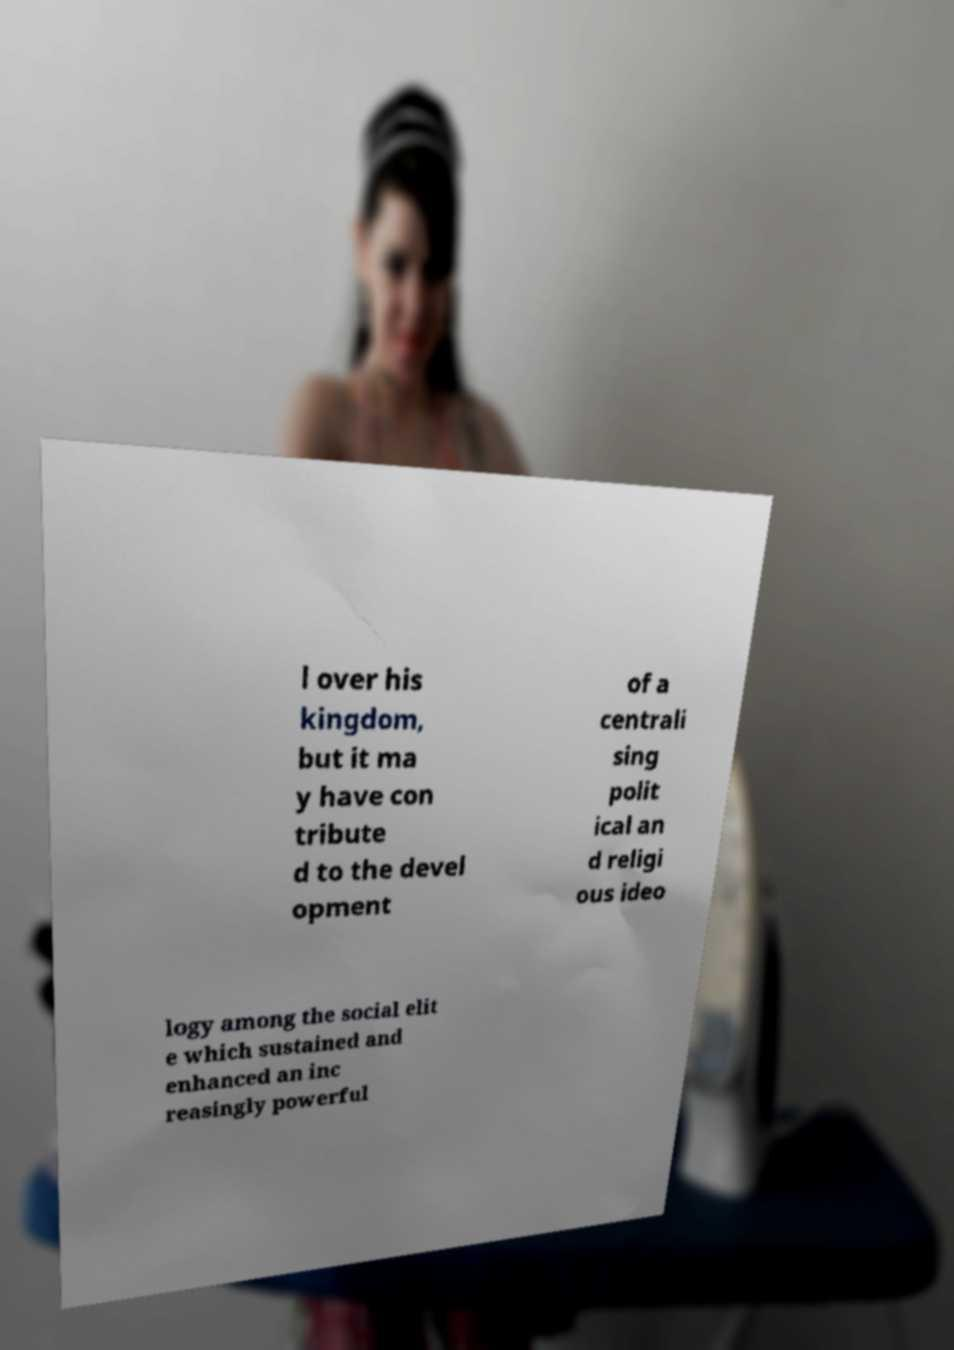Please read and relay the text visible in this image. What does it say? l over his kingdom, but it ma y have con tribute d to the devel opment of a centrali sing polit ical an d religi ous ideo logy among the social elit e which sustained and enhanced an inc reasingly powerful 